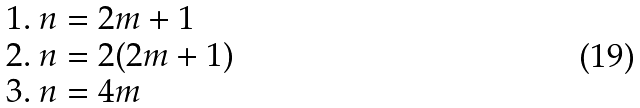<formula> <loc_0><loc_0><loc_500><loc_500>\begin{array} { l } 1 . \ n = 2 m + 1 \\ 2 . \ n = 2 ( 2 m + 1 ) \\ 3 . \ n = 4 m \end{array}</formula> 